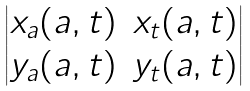<formula> <loc_0><loc_0><loc_500><loc_500>\begin{vmatrix} x _ { a } ( a , t ) & x _ { t } ( a , t ) \\ y _ { a } ( a , t ) & y _ { t } ( a , t ) \\ \end{vmatrix}</formula> 